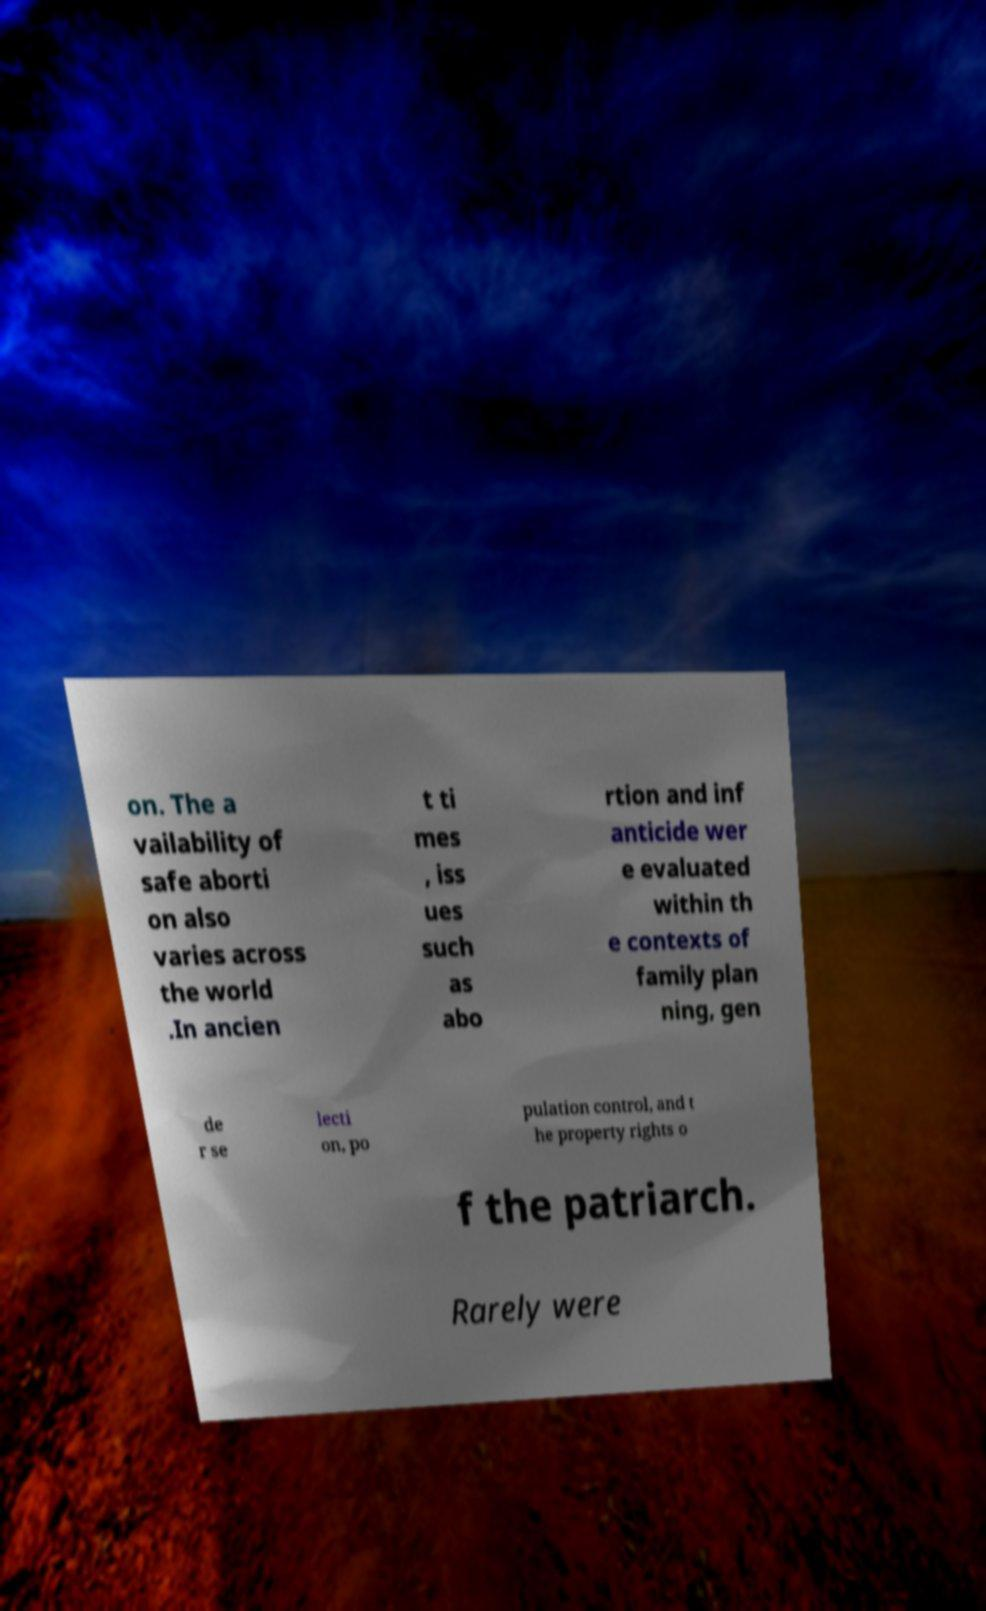Please identify and transcribe the text found in this image. on. The a vailability of safe aborti on also varies across the world .In ancien t ti mes , iss ues such as abo rtion and inf anticide wer e evaluated within th e contexts of family plan ning, gen de r se lecti on, po pulation control, and t he property rights o f the patriarch. Rarely were 